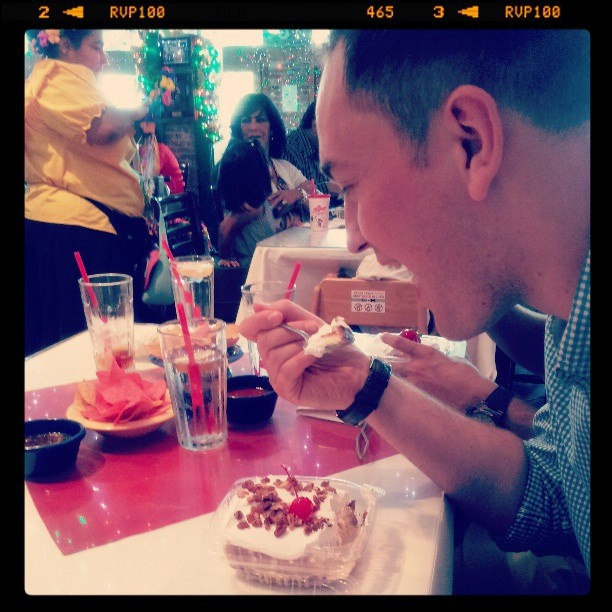Describe the objects in this image and their specific colors. I can see people in black, brown, navy, purple, and blue tones, dining table in black, tan, lightpink, salmon, and navy tones, people in black, navy, brown, and tan tones, dining table in black, brown, lightpink, darkgray, and tan tones, and people in black, navy, purple, blue, and darkgray tones in this image. 